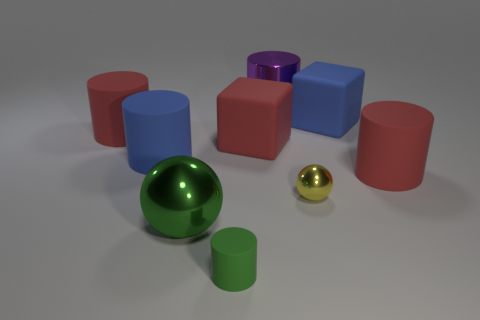How many metallic objects are either small gray spheres or big red cubes?
Your answer should be compact. 0. Are there more shiny cylinders that are on the left side of the blue rubber cylinder than blue metal cylinders?
Keep it short and to the point. No. What material is the large object in front of the small yellow metallic thing?
Make the answer very short. Metal. How many red cylinders have the same material as the big blue block?
Keep it short and to the point. 2. There is a red thing that is to the left of the yellow metallic ball and on the right side of the large green object; what shape is it?
Your answer should be compact. Cube. How many objects are cylinders in front of the small sphere or red things to the right of the green metal object?
Your response must be concise. 3. Are there an equal number of red cylinders that are on the right side of the metal cylinder and purple objects on the left side of the small rubber object?
Keep it short and to the point. No. There is a blue rubber object in front of the red matte cylinder that is left of the big purple metal cylinder; what shape is it?
Ensure brevity in your answer.  Cylinder. Is there a large matte thing of the same shape as the tiny matte object?
Give a very brief answer. Yes. How many big matte cubes are there?
Your answer should be compact. 2. 